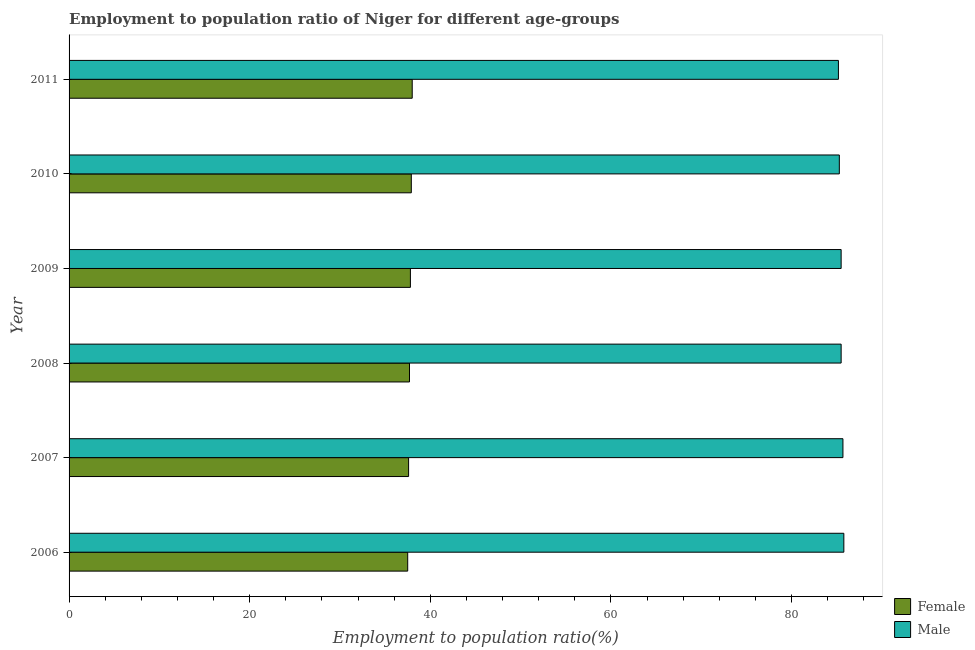How many different coloured bars are there?
Your response must be concise. 2. How many bars are there on the 5th tick from the top?
Your answer should be very brief. 2. How many bars are there on the 4th tick from the bottom?
Your response must be concise. 2. In how many cases, is the number of bars for a given year not equal to the number of legend labels?
Provide a succinct answer. 0. What is the employment to population ratio(female) in 2007?
Give a very brief answer. 37.6. Across all years, what is the minimum employment to population ratio(female)?
Give a very brief answer. 37.5. What is the total employment to population ratio(female) in the graph?
Ensure brevity in your answer.  226.5. What is the difference between the employment to population ratio(female) in 2009 and the employment to population ratio(male) in 2011?
Give a very brief answer. -47.4. What is the average employment to population ratio(female) per year?
Give a very brief answer. 37.75. In the year 2008, what is the difference between the employment to population ratio(male) and employment to population ratio(female)?
Keep it short and to the point. 47.8. What is the ratio of the employment to population ratio(female) in 2007 to that in 2010?
Provide a short and direct response. 0.99. Is the employment to population ratio(female) in 2009 less than that in 2010?
Keep it short and to the point. Yes. In how many years, is the employment to population ratio(female) greater than the average employment to population ratio(female) taken over all years?
Provide a succinct answer. 3. Is the sum of the employment to population ratio(female) in 2008 and 2011 greater than the maximum employment to population ratio(male) across all years?
Keep it short and to the point. No. How many bars are there?
Offer a terse response. 12. Are all the bars in the graph horizontal?
Provide a short and direct response. Yes. What is the difference between two consecutive major ticks on the X-axis?
Make the answer very short. 20. Where does the legend appear in the graph?
Give a very brief answer. Bottom right. How many legend labels are there?
Your answer should be compact. 2. What is the title of the graph?
Your response must be concise. Employment to population ratio of Niger for different age-groups. What is the Employment to population ratio(%) of Female in 2006?
Ensure brevity in your answer.  37.5. What is the Employment to population ratio(%) of Male in 2006?
Offer a terse response. 85.8. What is the Employment to population ratio(%) of Female in 2007?
Your response must be concise. 37.6. What is the Employment to population ratio(%) in Male in 2007?
Make the answer very short. 85.7. What is the Employment to population ratio(%) in Female in 2008?
Provide a succinct answer. 37.7. What is the Employment to population ratio(%) in Male in 2008?
Offer a very short reply. 85.5. What is the Employment to population ratio(%) in Female in 2009?
Make the answer very short. 37.8. What is the Employment to population ratio(%) of Male in 2009?
Keep it short and to the point. 85.5. What is the Employment to population ratio(%) of Female in 2010?
Make the answer very short. 37.9. What is the Employment to population ratio(%) in Male in 2010?
Offer a terse response. 85.3. What is the Employment to population ratio(%) of Female in 2011?
Keep it short and to the point. 38. What is the Employment to population ratio(%) in Male in 2011?
Your answer should be compact. 85.2. Across all years, what is the maximum Employment to population ratio(%) in Female?
Your response must be concise. 38. Across all years, what is the maximum Employment to population ratio(%) in Male?
Give a very brief answer. 85.8. Across all years, what is the minimum Employment to population ratio(%) of Female?
Provide a short and direct response. 37.5. Across all years, what is the minimum Employment to population ratio(%) in Male?
Keep it short and to the point. 85.2. What is the total Employment to population ratio(%) of Female in the graph?
Your answer should be very brief. 226.5. What is the total Employment to population ratio(%) in Male in the graph?
Your answer should be very brief. 513. What is the difference between the Employment to population ratio(%) in Female in 2006 and that in 2007?
Keep it short and to the point. -0.1. What is the difference between the Employment to population ratio(%) of Male in 2006 and that in 2007?
Your answer should be compact. 0.1. What is the difference between the Employment to population ratio(%) in Male in 2006 and that in 2008?
Offer a very short reply. 0.3. What is the difference between the Employment to population ratio(%) of Female in 2006 and that in 2009?
Give a very brief answer. -0.3. What is the difference between the Employment to population ratio(%) in Male in 2006 and that in 2009?
Provide a short and direct response. 0.3. What is the difference between the Employment to population ratio(%) of Male in 2006 and that in 2011?
Your answer should be compact. 0.6. What is the difference between the Employment to population ratio(%) of Female in 2007 and that in 2008?
Offer a terse response. -0.1. What is the difference between the Employment to population ratio(%) of Male in 2007 and that in 2008?
Ensure brevity in your answer.  0.2. What is the difference between the Employment to population ratio(%) in Female in 2007 and that in 2009?
Keep it short and to the point. -0.2. What is the difference between the Employment to population ratio(%) of Male in 2007 and that in 2009?
Make the answer very short. 0.2. What is the difference between the Employment to population ratio(%) of Male in 2007 and that in 2010?
Provide a succinct answer. 0.4. What is the difference between the Employment to population ratio(%) in Male in 2008 and that in 2009?
Offer a terse response. 0. What is the difference between the Employment to population ratio(%) in Female in 2008 and that in 2010?
Your response must be concise. -0.2. What is the difference between the Employment to population ratio(%) in Male in 2008 and that in 2010?
Keep it short and to the point. 0.2. What is the difference between the Employment to population ratio(%) of Female in 2008 and that in 2011?
Your answer should be very brief. -0.3. What is the difference between the Employment to population ratio(%) in Male in 2009 and that in 2011?
Ensure brevity in your answer.  0.3. What is the difference between the Employment to population ratio(%) in Female in 2006 and the Employment to population ratio(%) in Male in 2007?
Offer a very short reply. -48.2. What is the difference between the Employment to population ratio(%) of Female in 2006 and the Employment to population ratio(%) of Male in 2008?
Keep it short and to the point. -48. What is the difference between the Employment to population ratio(%) of Female in 2006 and the Employment to population ratio(%) of Male in 2009?
Your answer should be compact. -48. What is the difference between the Employment to population ratio(%) in Female in 2006 and the Employment to population ratio(%) in Male in 2010?
Make the answer very short. -47.8. What is the difference between the Employment to population ratio(%) of Female in 2006 and the Employment to population ratio(%) of Male in 2011?
Provide a short and direct response. -47.7. What is the difference between the Employment to population ratio(%) of Female in 2007 and the Employment to population ratio(%) of Male in 2008?
Offer a terse response. -47.9. What is the difference between the Employment to population ratio(%) of Female in 2007 and the Employment to population ratio(%) of Male in 2009?
Your answer should be very brief. -47.9. What is the difference between the Employment to population ratio(%) of Female in 2007 and the Employment to population ratio(%) of Male in 2010?
Provide a short and direct response. -47.7. What is the difference between the Employment to population ratio(%) of Female in 2007 and the Employment to population ratio(%) of Male in 2011?
Ensure brevity in your answer.  -47.6. What is the difference between the Employment to population ratio(%) of Female in 2008 and the Employment to population ratio(%) of Male in 2009?
Keep it short and to the point. -47.8. What is the difference between the Employment to population ratio(%) of Female in 2008 and the Employment to population ratio(%) of Male in 2010?
Offer a very short reply. -47.6. What is the difference between the Employment to population ratio(%) of Female in 2008 and the Employment to population ratio(%) of Male in 2011?
Provide a succinct answer. -47.5. What is the difference between the Employment to population ratio(%) in Female in 2009 and the Employment to population ratio(%) in Male in 2010?
Your response must be concise. -47.5. What is the difference between the Employment to population ratio(%) in Female in 2009 and the Employment to population ratio(%) in Male in 2011?
Your answer should be compact. -47.4. What is the difference between the Employment to population ratio(%) in Female in 2010 and the Employment to population ratio(%) in Male in 2011?
Offer a terse response. -47.3. What is the average Employment to population ratio(%) of Female per year?
Provide a short and direct response. 37.75. What is the average Employment to population ratio(%) of Male per year?
Keep it short and to the point. 85.5. In the year 2006, what is the difference between the Employment to population ratio(%) in Female and Employment to population ratio(%) in Male?
Your response must be concise. -48.3. In the year 2007, what is the difference between the Employment to population ratio(%) in Female and Employment to population ratio(%) in Male?
Ensure brevity in your answer.  -48.1. In the year 2008, what is the difference between the Employment to population ratio(%) of Female and Employment to population ratio(%) of Male?
Your answer should be compact. -47.8. In the year 2009, what is the difference between the Employment to population ratio(%) of Female and Employment to population ratio(%) of Male?
Give a very brief answer. -47.7. In the year 2010, what is the difference between the Employment to population ratio(%) in Female and Employment to population ratio(%) in Male?
Offer a very short reply. -47.4. In the year 2011, what is the difference between the Employment to population ratio(%) of Female and Employment to population ratio(%) of Male?
Give a very brief answer. -47.2. What is the ratio of the Employment to population ratio(%) in Male in 2006 to that in 2007?
Keep it short and to the point. 1. What is the ratio of the Employment to population ratio(%) of Male in 2006 to that in 2008?
Your response must be concise. 1. What is the ratio of the Employment to population ratio(%) in Female in 2006 to that in 2009?
Your answer should be very brief. 0.99. What is the ratio of the Employment to population ratio(%) of Female in 2006 to that in 2010?
Ensure brevity in your answer.  0.99. What is the ratio of the Employment to population ratio(%) of Male in 2006 to that in 2010?
Your response must be concise. 1.01. What is the ratio of the Employment to population ratio(%) of Female in 2006 to that in 2011?
Offer a very short reply. 0.99. What is the ratio of the Employment to population ratio(%) in Male in 2006 to that in 2011?
Your answer should be very brief. 1.01. What is the ratio of the Employment to population ratio(%) in Female in 2007 to that in 2008?
Keep it short and to the point. 1. What is the ratio of the Employment to population ratio(%) of Male in 2007 to that in 2008?
Your answer should be very brief. 1. What is the ratio of the Employment to population ratio(%) of Male in 2007 to that in 2009?
Give a very brief answer. 1. What is the ratio of the Employment to population ratio(%) in Male in 2007 to that in 2010?
Ensure brevity in your answer.  1. What is the ratio of the Employment to population ratio(%) of Female in 2007 to that in 2011?
Your answer should be very brief. 0.99. What is the ratio of the Employment to population ratio(%) in Male in 2007 to that in 2011?
Keep it short and to the point. 1.01. What is the ratio of the Employment to population ratio(%) of Female in 2008 to that in 2009?
Offer a terse response. 1. What is the ratio of the Employment to population ratio(%) of Male in 2008 to that in 2009?
Offer a terse response. 1. What is the ratio of the Employment to population ratio(%) of Female in 2008 to that in 2010?
Make the answer very short. 0.99. What is the ratio of the Employment to population ratio(%) of Male in 2008 to that in 2010?
Your response must be concise. 1. What is the ratio of the Employment to population ratio(%) of Female in 2008 to that in 2011?
Ensure brevity in your answer.  0.99. What is the ratio of the Employment to population ratio(%) of Female in 2009 to that in 2010?
Offer a terse response. 1. What is the ratio of the Employment to population ratio(%) in Male in 2009 to that in 2010?
Give a very brief answer. 1. What is the ratio of the Employment to population ratio(%) of Male in 2009 to that in 2011?
Ensure brevity in your answer.  1. What is the ratio of the Employment to population ratio(%) in Male in 2010 to that in 2011?
Provide a short and direct response. 1. 